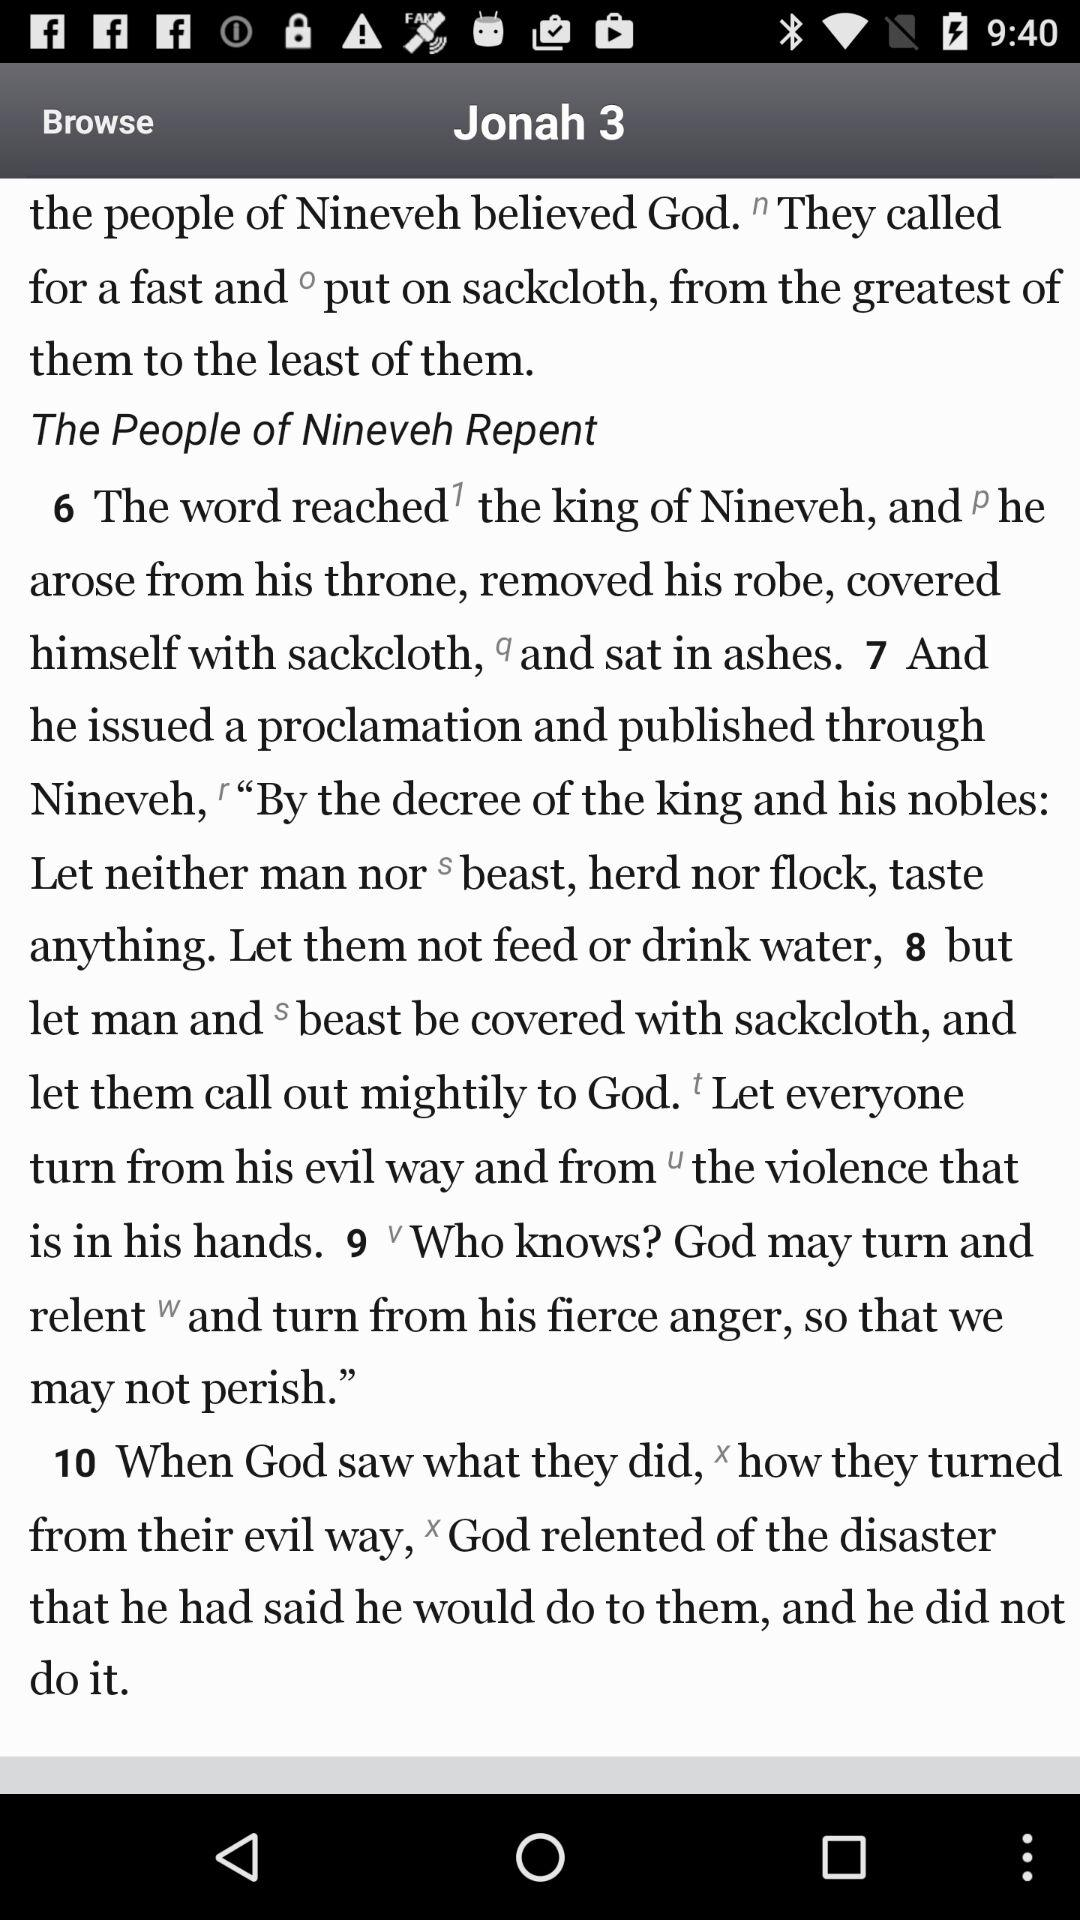What is the name of the book? The name of the book is "Jonah". 